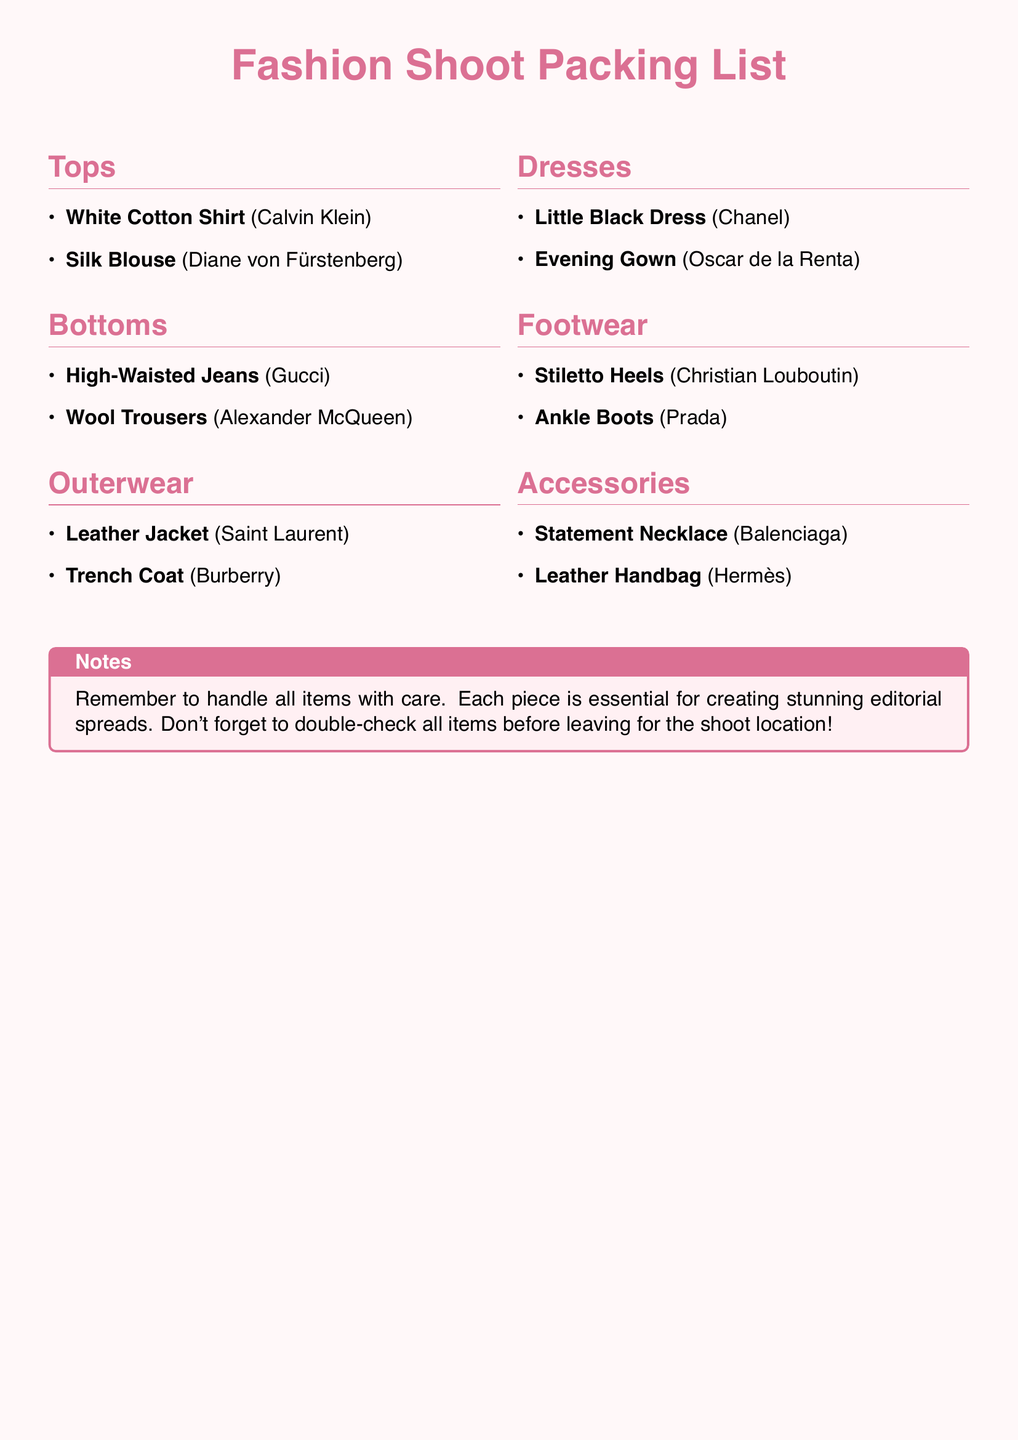what is the brand of the Silk Blouse? The document lists the brand associated with the Silk Blouse, which is Diane von Fürstenberg.
Answer: Diane von Fürstenberg how many types of footwear are listed? The document details the types of footwear included, highlighting two specific pairs: Stiletto Heels and Ankle Boots.
Answer: 2 which item is categorized under Accessories? The document specifies the items under the Accessories category, one of which is the Statement Necklace.
Answer: Statement Necklace name one designer of the Outerwear section. The document includes multiple designers in the Outerwear section, one of which is Saint Laurent.
Answer: Saint Laurent how many dresses are listed on the packing list? The document shows two types of dresses: Little Black Dress and Evening Gown, indicating their total.
Answer: 2 what note is included in the packing list? The document includes a note reminding to handle items with care and to double-check before leaving for the shoot.
Answer: Handle all items with care which outerwear item is from Burberry? The document clearly states that the Trench Coat is from Burberry, identifying the item associated with this brand.
Answer: Trench Coat list one type of bottom in the document. The document outlines two bottoms, one of which is High-Waisted Jeans.
Answer: High-Waisted Jeans what color is the background of the document? The document describes the overall color scheme, particularly noting light pink as the background color.
Answer: Light pink 